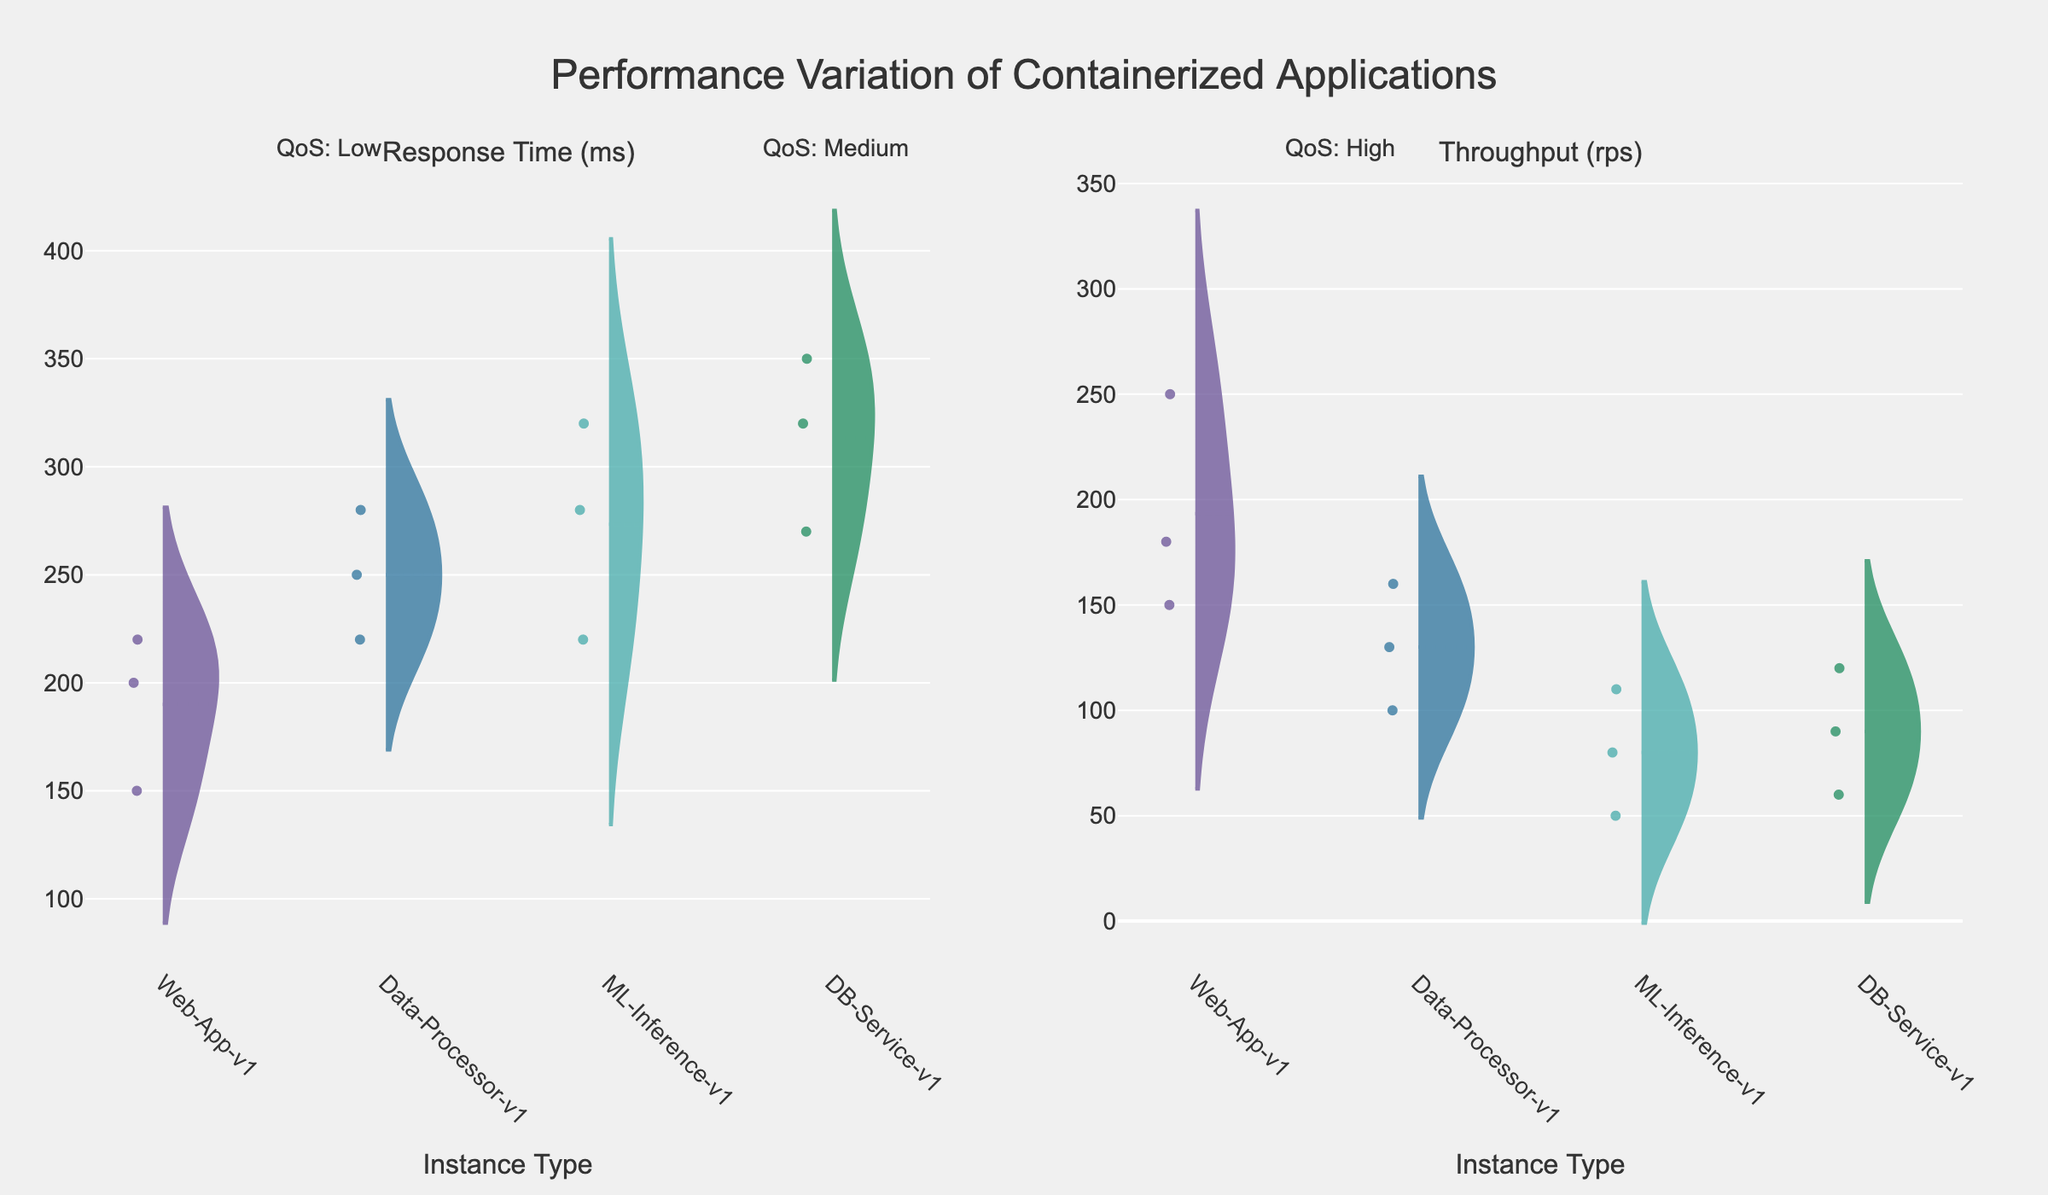What is the title of the plot? The explanatory title can be found at the top of the figure. It usually helps summarize the content of the plots.
Answer: Performance Variation of Containerized Applications Which instance type shows the lowest response time under high QoS? From the left plot under high QoS, identify the violin plot with the lowest values along the y-axis for response time.
Answer: Web-App-v1 Which instance type has the highest throughput under medium QoS? By examining the right plot under medium QoS, find the violin plot with the highest values along the y-axis for throughput.
Answer: Web-App-v1 What is the range of response times for ML-Inference-v1 under low QoS? In the left plot, locate the ML-Inference-v1 violin plot under low QoS. Range is from the minimum to maximum data points.
Answer: 320 ms Is the response time more variable for Web-App-v1 or Data-Processor-v1 under low QoS? Compare the spread (width) of the violin plots for both instance types in the left plot under low QoS. Wider plots indicate more variability.
Answer: Data-Processor-v1 How does the average throughput of DB-Service-v1 under high QoS compare to its low QoS? The average throughput is indicated by the mean line in the violin plot. Compare the mean line positions of DB-Service-v1 under high and low QoS in the right plot.
Answer: Higher in high QoS Which instance type exhibits the most significant improvement in response time when switching from low to high QoS? Look for the instance type whose response time violin plot shows the greatest difference in median line position from low to high QoS in the left plot.
Answer: ML-Inference-v1 Do any instance types have overlapping throughput ranges across different QoS levels? In the right plot, identify if any of the violin plots for a given instance type at different QoS levels overlap in their y-values.
Answer: Yes Which instance type's throughput is least affected by changes in QoS levels? In the right plot, evaluate which instance type has the smallest variation in throughput between low, medium, and high QoS levels.
Answer: ML-Inference-v1 